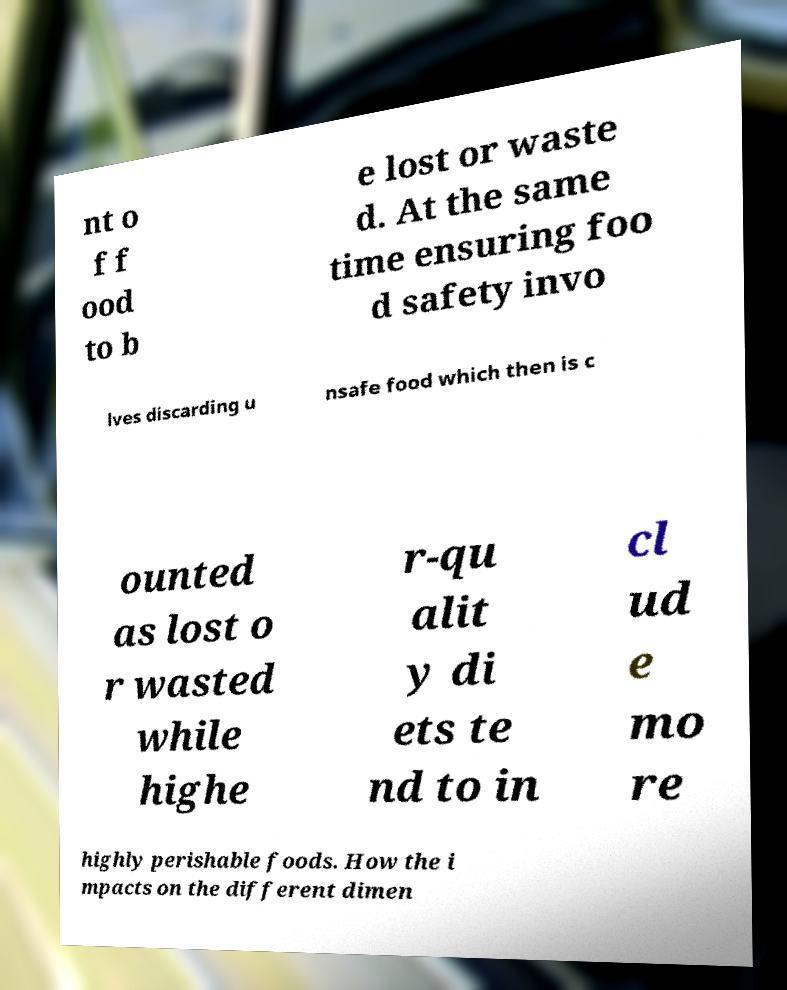Can you read and provide the text displayed in the image?This photo seems to have some interesting text. Can you extract and type it out for me? nt o f f ood to b e lost or waste d. At the same time ensuring foo d safety invo lves discarding u nsafe food which then is c ounted as lost o r wasted while highe r-qu alit y di ets te nd to in cl ud e mo re highly perishable foods. How the i mpacts on the different dimen 